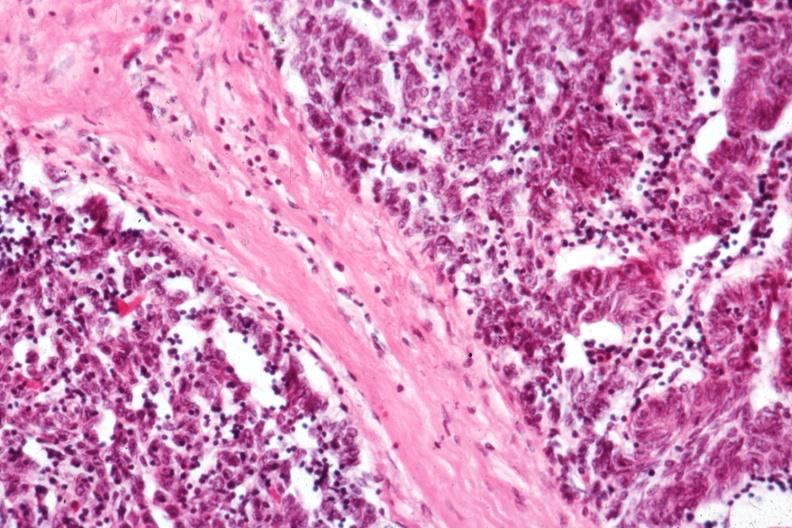s hematologic present?
Answer the question using a single word or phrase. Yes 